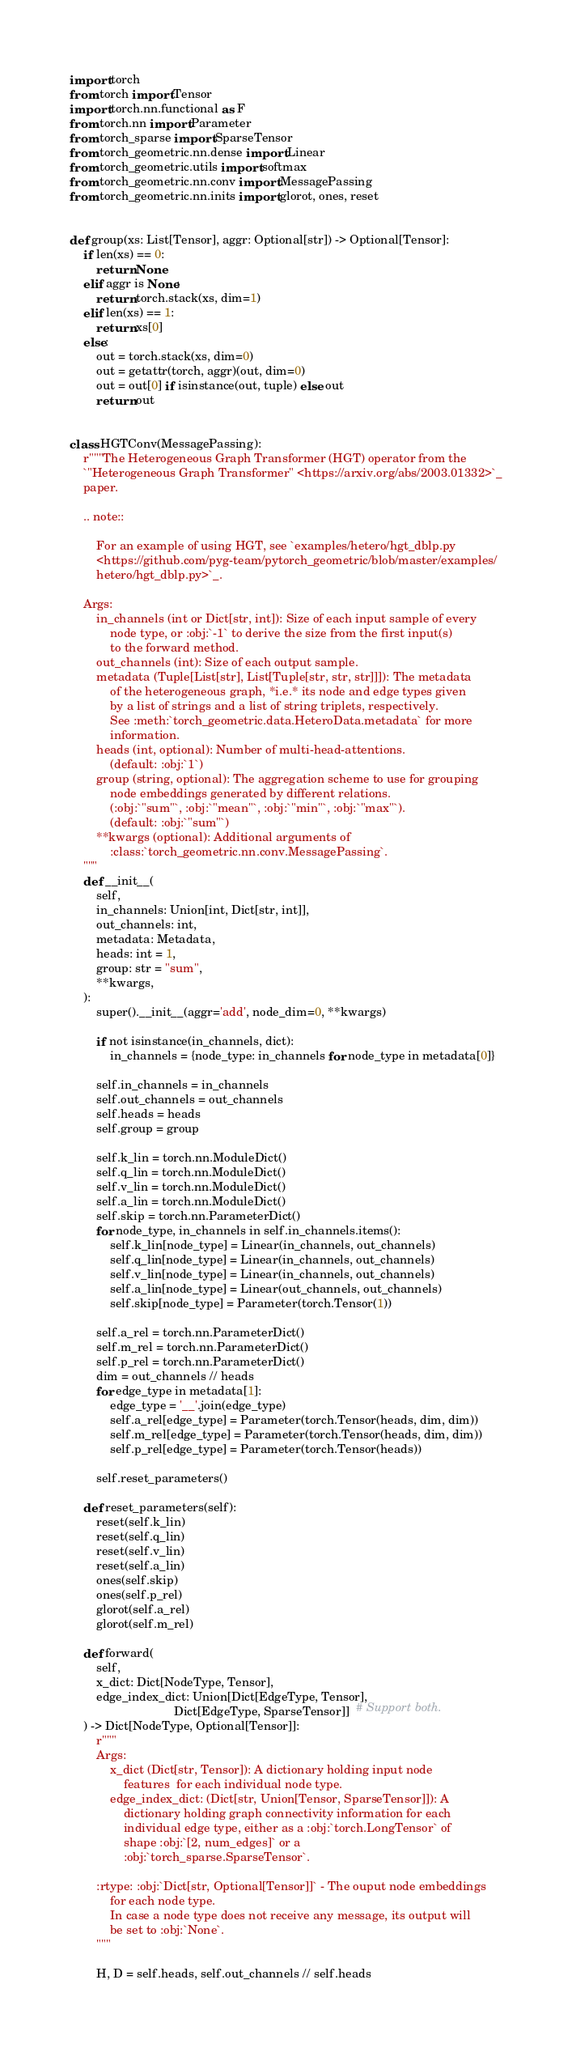<code> <loc_0><loc_0><loc_500><loc_500><_Python_>import torch
from torch import Tensor
import torch.nn.functional as F
from torch.nn import Parameter
from torch_sparse import SparseTensor
from torch_geometric.nn.dense import Linear
from torch_geometric.utils import softmax
from torch_geometric.nn.conv import MessagePassing
from torch_geometric.nn.inits import glorot, ones, reset


def group(xs: List[Tensor], aggr: Optional[str]) -> Optional[Tensor]:
    if len(xs) == 0:
        return None
    elif aggr is None:
        return torch.stack(xs, dim=1)
    elif len(xs) == 1:
        return xs[0]
    else:
        out = torch.stack(xs, dim=0)
        out = getattr(torch, aggr)(out, dim=0)
        out = out[0] if isinstance(out, tuple) else out
        return out


class HGTConv(MessagePassing):
    r"""The Heterogeneous Graph Transformer (HGT) operator from the
    `"Heterogeneous Graph Transformer" <https://arxiv.org/abs/2003.01332>`_
    paper.

    .. note::

        For an example of using HGT, see `examples/hetero/hgt_dblp.py
        <https://github.com/pyg-team/pytorch_geometric/blob/master/examples/
        hetero/hgt_dblp.py>`_.

    Args:
        in_channels (int or Dict[str, int]): Size of each input sample of every
            node type, or :obj:`-1` to derive the size from the first input(s)
            to the forward method.
        out_channels (int): Size of each output sample.
        metadata (Tuple[List[str], List[Tuple[str, str, str]]]): The metadata
            of the heterogeneous graph, *i.e.* its node and edge types given
            by a list of strings and a list of string triplets, respectively.
            See :meth:`torch_geometric.data.HeteroData.metadata` for more
            information.
        heads (int, optional): Number of multi-head-attentions.
            (default: :obj:`1`)
        group (string, optional): The aggregation scheme to use for grouping
            node embeddings generated by different relations.
            (:obj:`"sum"`, :obj:`"mean"`, :obj:`"min"`, :obj:`"max"`).
            (default: :obj:`"sum"`)
        **kwargs (optional): Additional arguments of
            :class:`torch_geometric.nn.conv.MessagePassing`.
    """
    def __init__(
        self,
        in_channels: Union[int, Dict[str, int]],
        out_channels: int,
        metadata: Metadata,
        heads: int = 1,
        group: str = "sum",
        **kwargs,
    ):
        super().__init__(aggr='add', node_dim=0, **kwargs)

        if not isinstance(in_channels, dict):
            in_channels = {node_type: in_channels for node_type in metadata[0]}

        self.in_channels = in_channels
        self.out_channels = out_channels
        self.heads = heads
        self.group = group

        self.k_lin = torch.nn.ModuleDict()
        self.q_lin = torch.nn.ModuleDict()
        self.v_lin = torch.nn.ModuleDict()
        self.a_lin = torch.nn.ModuleDict()
        self.skip = torch.nn.ParameterDict()
        for node_type, in_channels in self.in_channels.items():
            self.k_lin[node_type] = Linear(in_channels, out_channels)
            self.q_lin[node_type] = Linear(in_channels, out_channels)
            self.v_lin[node_type] = Linear(in_channels, out_channels)
            self.a_lin[node_type] = Linear(out_channels, out_channels)
            self.skip[node_type] = Parameter(torch.Tensor(1))

        self.a_rel = torch.nn.ParameterDict()
        self.m_rel = torch.nn.ParameterDict()
        self.p_rel = torch.nn.ParameterDict()
        dim = out_channels // heads
        for edge_type in metadata[1]:
            edge_type = '__'.join(edge_type)
            self.a_rel[edge_type] = Parameter(torch.Tensor(heads, dim, dim))
            self.m_rel[edge_type] = Parameter(torch.Tensor(heads, dim, dim))
            self.p_rel[edge_type] = Parameter(torch.Tensor(heads))

        self.reset_parameters()

    def reset_parameters(self):
        reset(self.k_lin)
        reset(self.q_lin)
        reset(self.v_lin)
        reset(self.a_lin)
        ones(self.skip)
        ones(self.p_rel)
        glorot(self.a_rel)
        glorot(self.m_rel)

    def forward(
        self,
        x_dict: Dict[NodeType, Tensor],
        edge_index_dict: Union[Dict[EdgeType, Tensor],
                               Dict[EdgeType, SparseTensor]]  # Support both.
    ) -> Dict[NodeType, Optional[Tensor]]:
        r"""
        Args:
            x_dict (Dict[str, Tensor]): A dictionary holding input node
                features  for each individual node type.
            edge_index_dict: (Dict[str, Union[Tensor, SparseTensor]]): A
                dictionary holding graph connectivity information for each
                individual edge type, either as a :obj:`torch.LongTensor` of
                shape :obj:`[2, num_edges]` or a
                :obj:`torch_sparse.SparseTensor`.

        :rtype: :obj:`Dict[str, Optional[Tensor]]` - The ouput node embeddings
            for each node type.
            In case a node type does not receive any message, its output will
            be set to :obj:`None`.
        """

        H, D = self.heads, self.out_channels // self.heads
</code> 